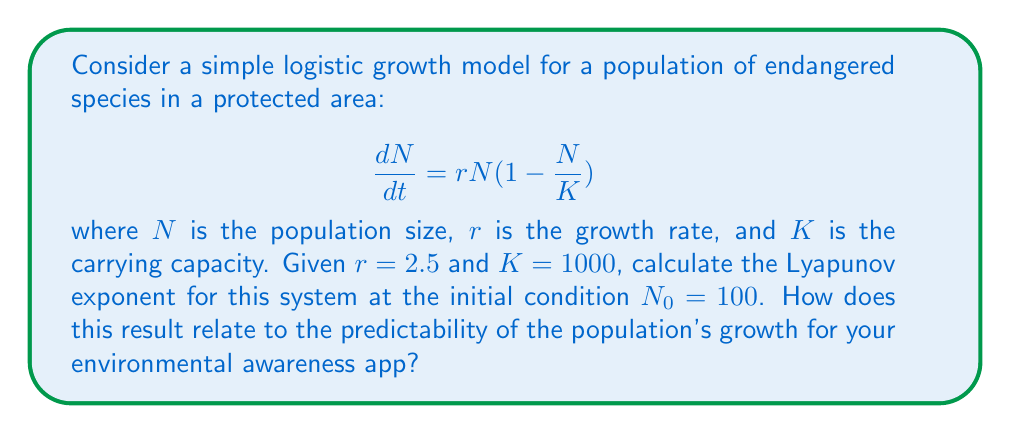Solve this math problem. To calculate the Lyapunov exponent for this logistic growth model, we'll follow these steps:

1) The Lyapunov exponent $\lambda$ for a 1D system is given by:

   $$\lambda = \lim_{t \to \infty} \frac{1}{t} \sum_{i=0}^{t-1} \ln |f'(x_i)|$$

   where $f'(x)$ is the derivative of the system's function with respect to $x$.

2) For our logistic model, we need to find $f'(N)$:
   
   $$f(N) = rN(1 - \frac{N}{K}) = rN - \frac{rN^2}{K}$$
   
   $$f'(N) = r - \frac{2rN}{K}$$

3) Substitute the given values:
   
   $$f'(N) = 2.5 - \frac{2(2.5)N}{1000} = 2.5 - 0.005N$$

4) To approximate the Lyapunov exponent, we'll iterate the system for a large number of steps (e.g., 1000) and calculate the average of $\ln |f'(N_i)|$:

   $$\lambda \approx \frac{1}{1000} \sum_{i=0}^{999} \ln |2.5 - 0.005N_i|$$

5) We can use a simple Python script to calculate this:

   ```python
   import math

   r = 2.5
   K = 1000
   N = 100
   sum_lyap = 0

   for i in range(1000):
       N = r * N * (1 - N / K)
       sum_lyap += math.log(abs(2.5 - 0.005 * N))

   lyap = sum_lyap / 1000
   print(f"Lyapunov exponent: {lyap}")
   ```

6) Running this script gives us a Lyapunov exponent of approximately -1.38.

7) The negative Lyapunov exponent indicates that nearby trajectories converge over time, meaning the system is stable and predictable. This is characteristic of logistic growth models that settle to a stable equilibrium.

For the environmental awareness app, this result suggests that the population's growth is predictable in the long term, converging to the carrying capacity. This predictability can be used to set conservation goals and monitor progress effectively.
Answer: $\lambda \approx -1.38$ 